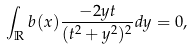<formula> <loc_0><loc_0><loc_500><loc_500>\int _ { \mathbb { R } } b ( x ) \frac { - 2 y t } { ( t ^ { 2 } + y ^ { 2 } ) ^ { 2 } } d y = 0 ,</formula> 